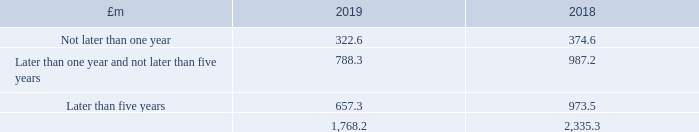26 Operating leases
The Group earns rental income by leasing its investment properties to tenants under operating leases.
In the UK the standard shopping centre lease is for a term of 10 to 15 years. Standard lease provisions include service charge payments, recovery of other direct costs and review every five years to market rent. Standard turnover-based leases have a turnover percentage agreed with each lessee which is applied to a retail unit’s annual sales and any excess between the resulting turnover rent and the minimum rent is receivable by the Group and recognised as income in the period in which it arises.
The Group’s secure rental income profile is underpinned by long lease lengths (as mentioned above), high occupancy and upward only rent reviews.
The future minimum lease amounts receivable by the Group under non-cancellable operating leases for continuing operations are as follows:
The income statement includes £12.7 million (2018: £14.4 million) recognised in respect of contingent rents calculated by reference to tenants’ turnover.
What is the amount of contingent rents calculated by reference to tenants' turnover in 2019? £12.7 million. How long is the lease for a standard shopping centre in the UK? 10 to 15 years. What is the amount of contingent rents calculated by reference to tenants' turnover in 2018? £14.4 million. What is the percentage change in the amount of contingent rents calculated by reference to tenants' turnover from 2018 to 2019?
Answer scale should be: percent. (12.7-14.4)/14.4
Answer: -11.81. In which year is there  higher future minimum lease amounts receivable? Find the year with the higher future minimum lease amounts receivable?
Answer: 2018. What is the percentage change in the future minimum lease amount receivable later than five years from to 2018 to 2019?
Answer scale should be: percent. (657.3-973.5)/973.5
Answer: -32.48. 